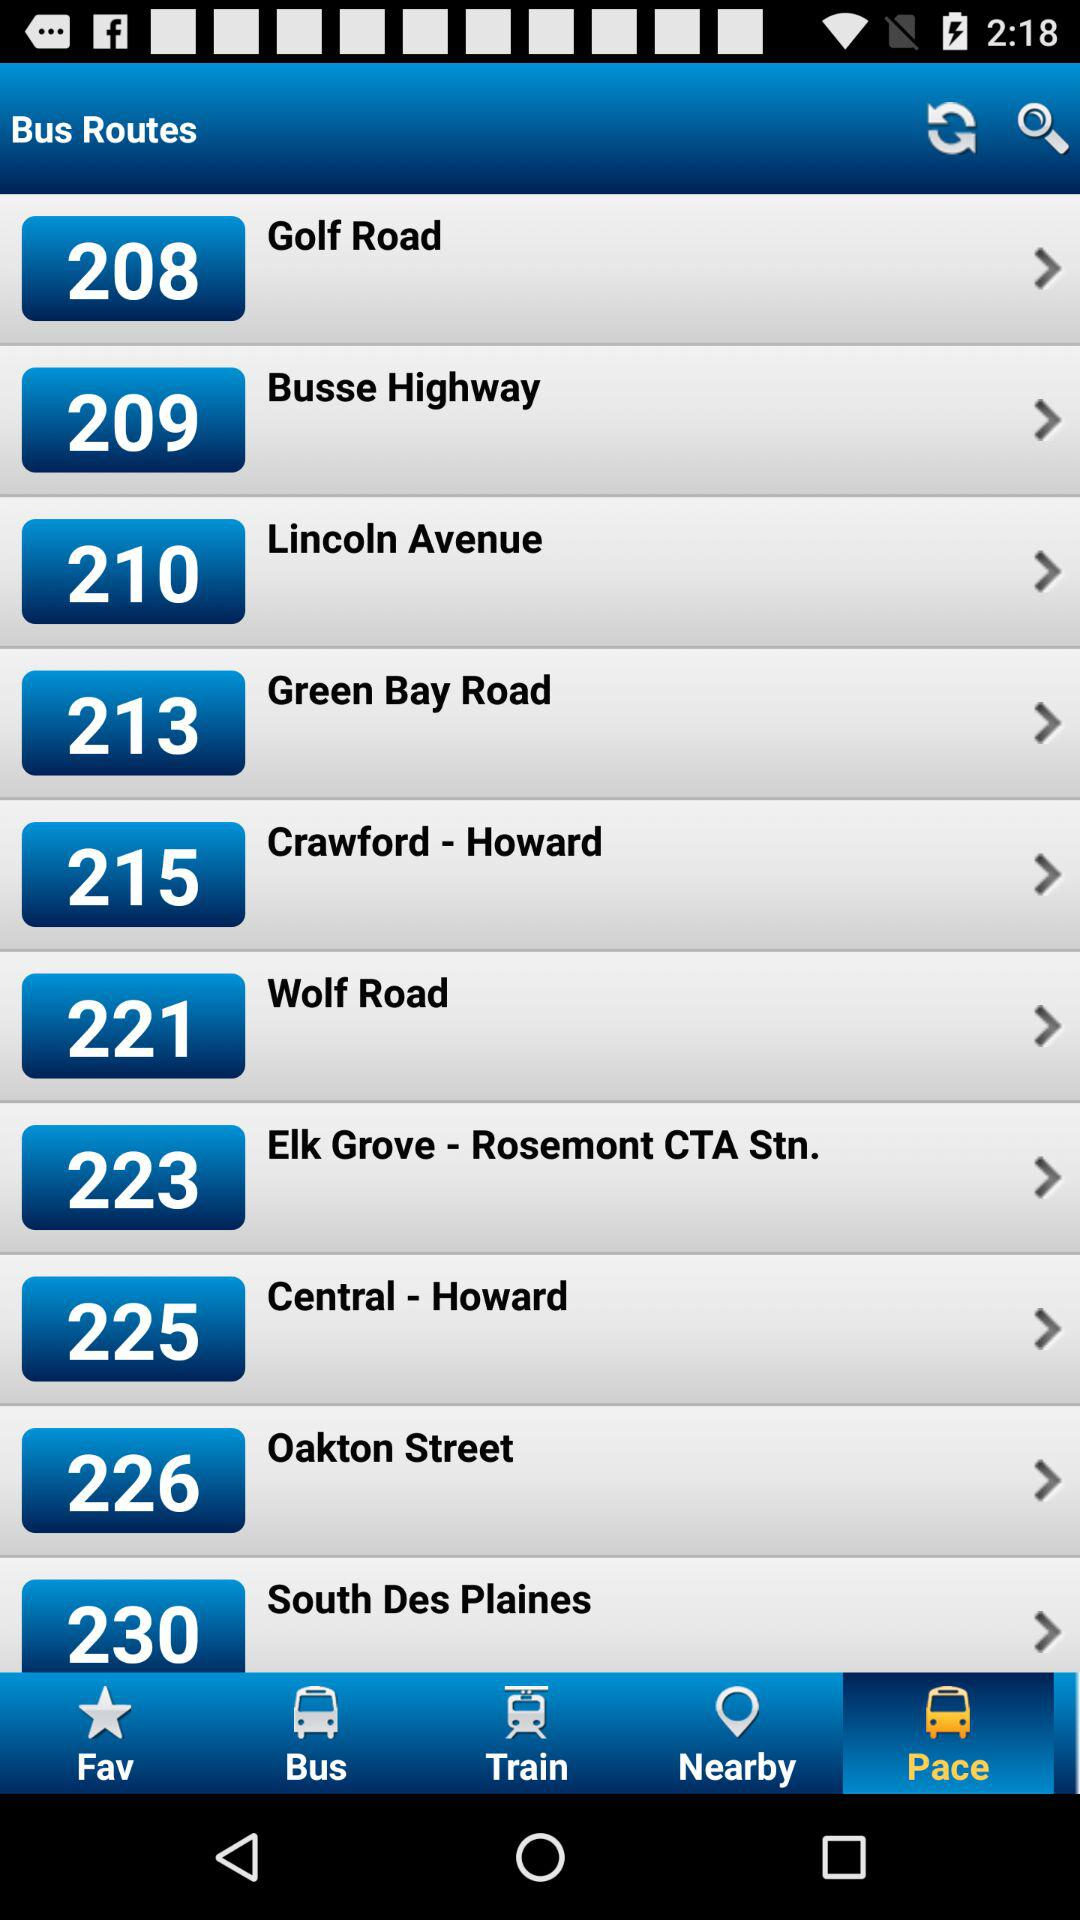How many bus routes are there in total? The screen shows a partial list of bus routes; however, the full extent is not visible. From what is presented, we see routes numbered 208, 209, 210, 213, 215, 221, 223, 225, 226, and 230. Assuming the screen continues beyond what is captured, there are likely more routes available than the 10 listed here. 